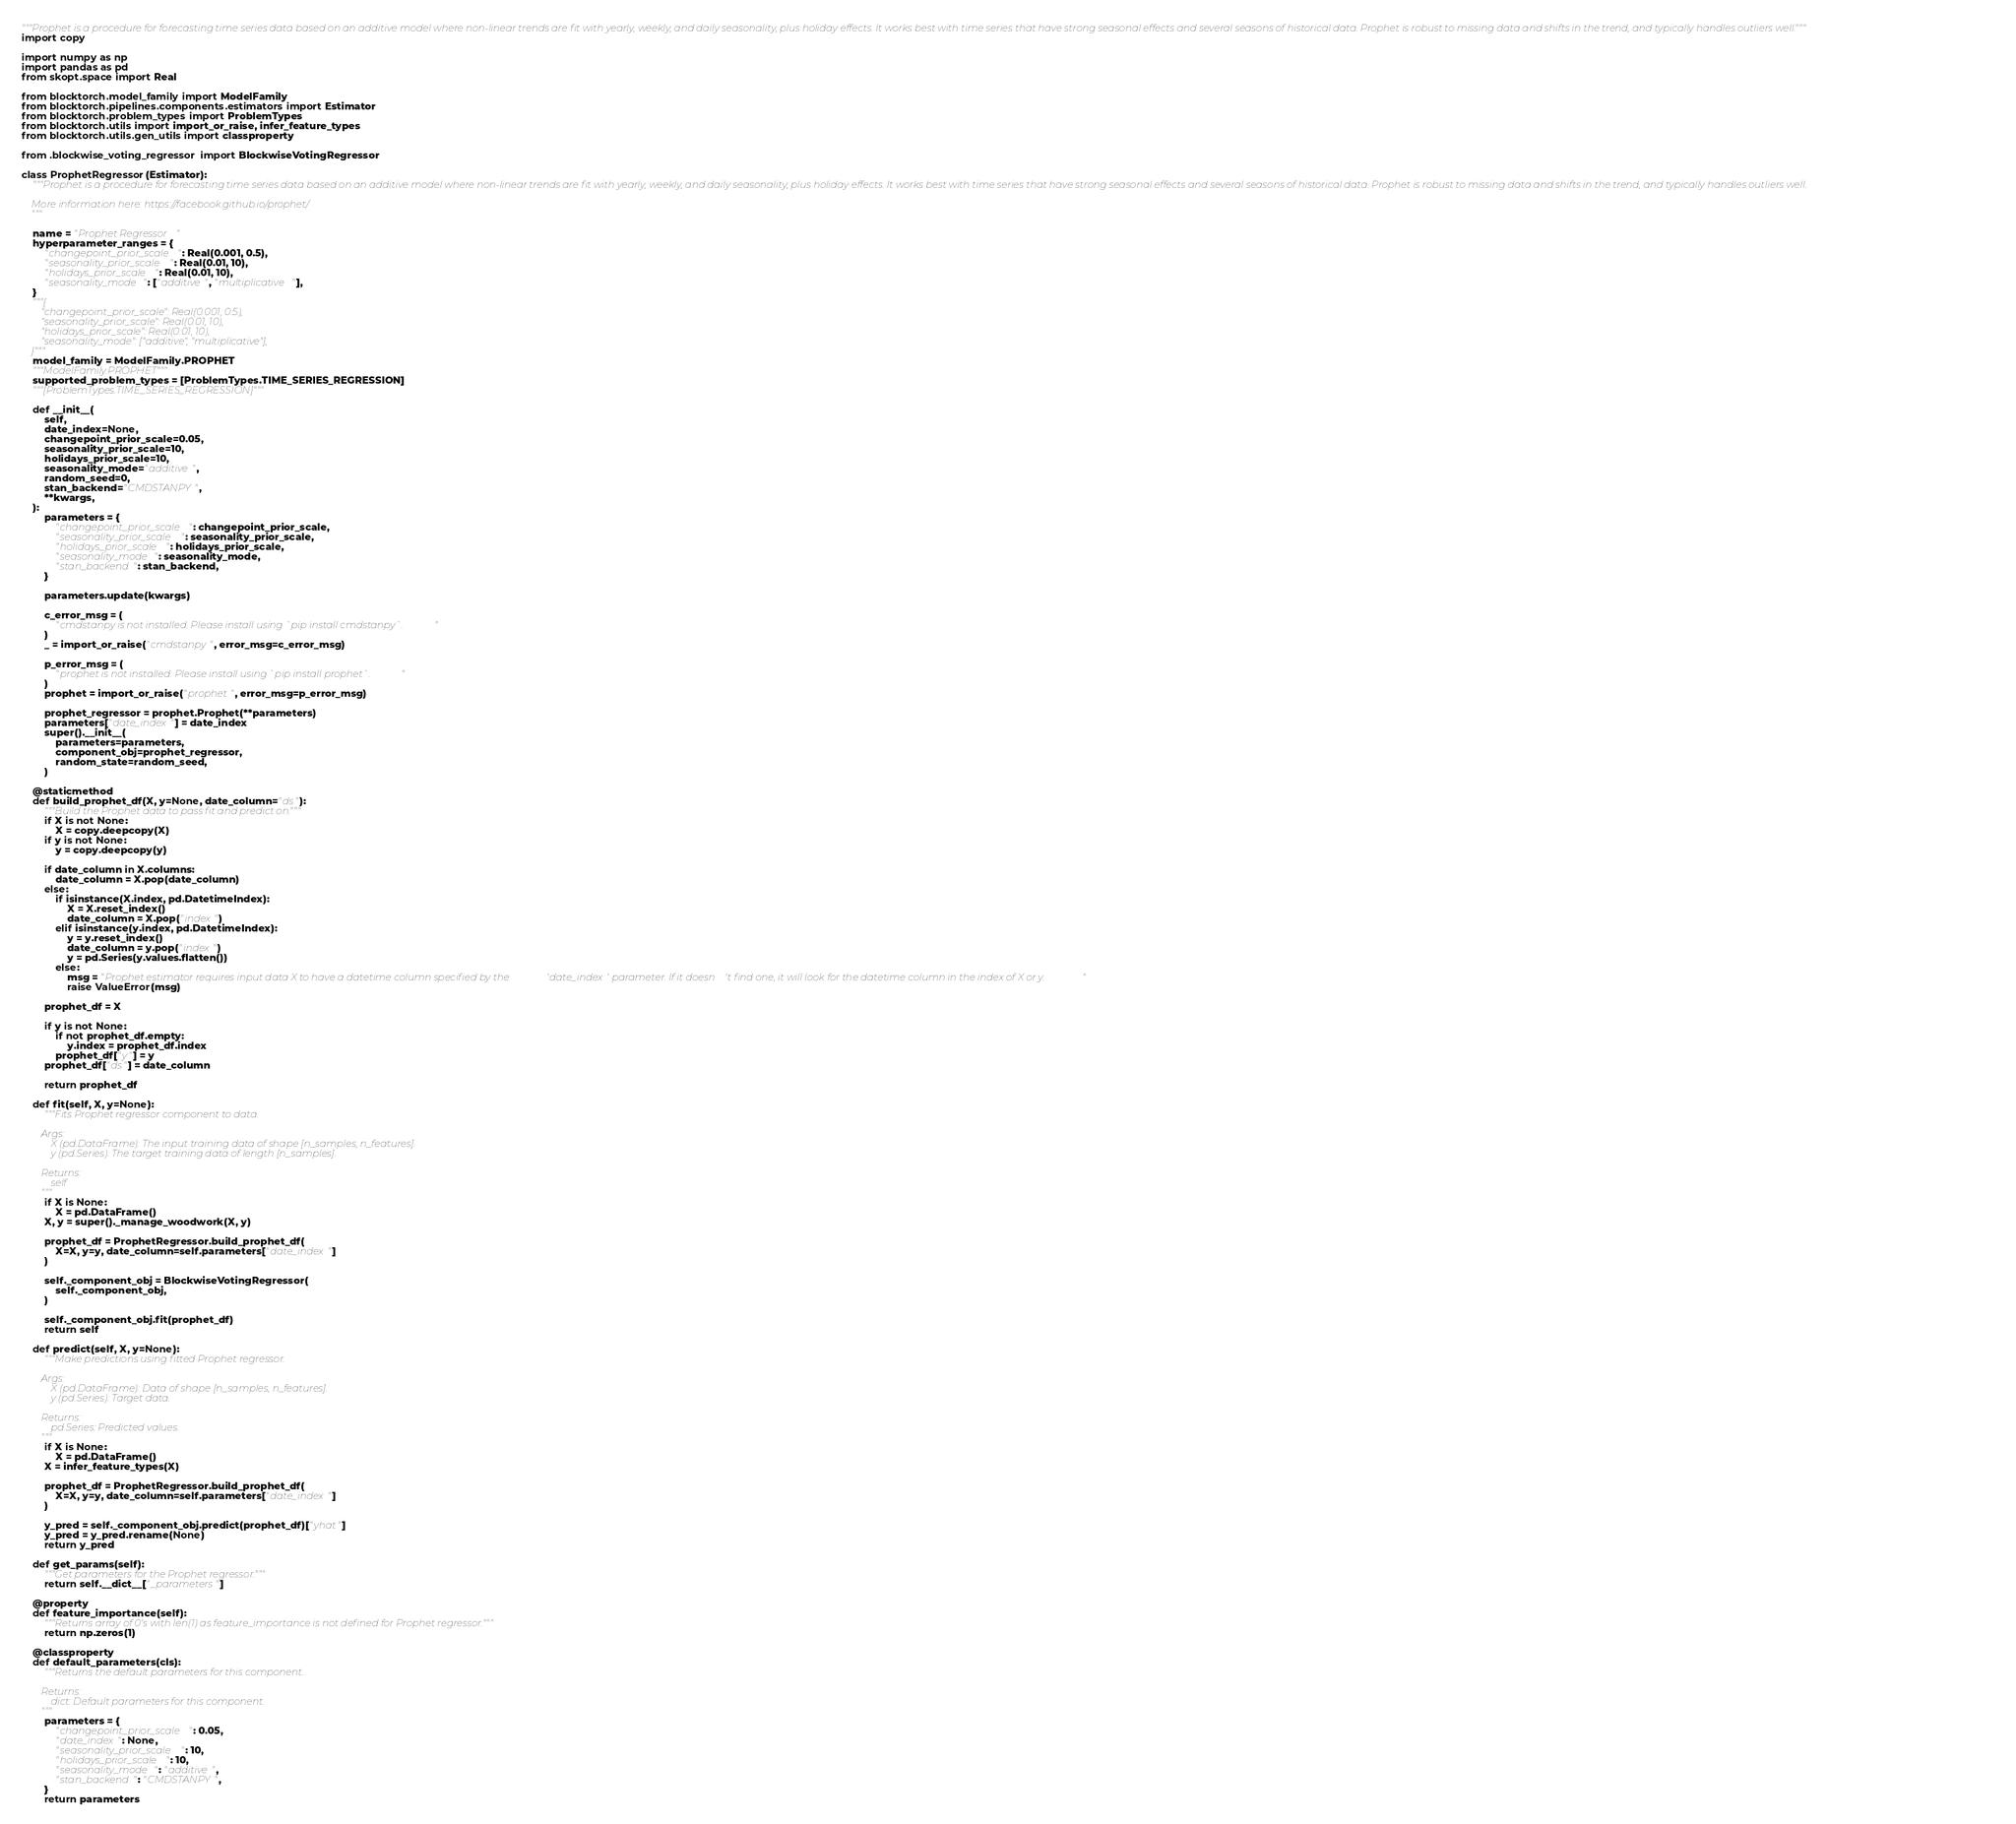<code> <loc_0><loc_0><loc_500><loc_500><_Python_>"""Prophet is a procedure for forecasting time series data based on an additive model where non-linear trends are fit with yearly, weekly, and daily seasonality, plus holiday effects. It works best with time series that have strong seasonal effects and several seasons of historical data. Prophet is robust to missing data and shifts in the trend, and typically handles outliers well."""
import copy

import numpy as np
import pandas as pd
from skopt.space import Real

from blocktorch.model_family import ModelFamily
from blocktorch.pipelines.components.estimators import Estimator
from blocktorch.problem_types import ProblemTypes
from blocktorch.utils import import_or_raise, infer_feature_types
from blocktorch.utils.gen_utils import classproperty

from .blockwise_voting_regressor import BlockwiseVotingRegressor

class ProphetRegressor(Estimator):
    """Prophet is a procedure for forecasting time series data based on an additive model where non-linear trends are fit with yearly, weekly, and daily seasonality, plus holiday effects. It works best with time series that have strong seasonal effects and several seasons of historical data. Prophet is robust to missing data and shifts in the trend, and typically handles outliers well.

    More information here: https://facebook.github.io/prophet/
    """

    name = "Prophet Regressor"
    hyperparameter_ranges = {
        "changepoint_prior_scale": Real(0.001, 0.5),
        "seasonality_prior_scale": Real(0.01, 10),
        "holidays_prior_scale": Real(0.01, 10),
        "seasonality_mode": ["additive", "multiplicative"],
    }
    """{
        "changepoint_prior_scale": Real(0.001, 0.5),
        "seasonality_prior_scale": Real(0.01, 10),
        "holidays_prior_scale": Real(0.01, 10),
        "seasonality_mode": ["additive", "multiplicative"],
    }"""
    model_family = ModelFamily.PROPHET
    """ModelFamily.PROPHET"""
    supported_problem_types = [ProblemTypes.TIME_SERIES_REGRESSION]
    """[ProblemTypes.TIME_SERIES_REGRESSION]"""

    def __init__(
        self,
        date_index=None,
        changepoint_prior_scale=0.05,
        seasonality_prior_scale=10,
        holidays_prior_scale=10,
        seasonality_mode="additive",
        random_seed=0,
        stan_backend="CMDSTANPY",
        **kwargs,
    ):
        parameters = {
            "changepoint_prior_scale": changepoint_prior_scale,
            "seasonality_prior_scale": seasonality_prior_scale,
            "holidays_prior_scale": holidays_prior_scale,
            "seasonality_mode": seasonality_mode,
            "stan_backend": stan_backend,
        }

        parameters.update(kwargs)

        c_error_msg = (
            "cmdstanpy is not installed. Please install using `pip install cmdstanpy`."
        )
        _ = import_or_raise("cmdstanpy", error_msg=c_error_msg)

        p_error_msg = (
            "prophet is not installed. Please install using `pip install prophet`."
        )
        prophet = import_or_raise("prophet", error_msg=p_error_msg)

        prophet_regressor = prophet.Prophet(**parameters)
        parameters["date_index"] = date_index
        super().__init__(
            parameters=parameters,
            component_obj=prophet_regressor,
            random_state=random_seed,
        )

    @staticmethod
    def build_prophet_df(X, y=None, date_column="ds"):
        """Build the Prophet data to pass fit and predict on."""
        if X is not None:
            X = copy.deepcopy(X)
        if y is not None:
            y = copy.deepcopy(y)

        if date_column in X.columns:
            date_column = X.pop(date_column)
        else:
            if isinstance(X.index, pd.DatetimeIndex):
                X = X.reset_index()
                date_column = X.pop("index")
            elif isinstance(y.index, pd.DatetimeIndex):
                y = y.reset_index()
                date_column = y.pop("index")
                y = pd.Series(y.values.flatten())
            else:
                msg = "Prophet estimator requires input data X to have a datetime column specified by the 'date_index' parameter. If it doesn't find one, it will look for the datetime column in the index of X or y."
                raise ValueError(msg)

        prophet_df = X

        if y is not None:
            if not prophet_df.empty:
                y.index = prophet_df.index
            prophet_df["y"] = y
        prophet_df["ds"] = date_column

        return prophet_df

    def fit(self, X, y=None):
        """Fits Prophet regressor component to data.

        Args:
            X (pd.DataFrame): The input training data of shape [n_samples, n_features].
            y (pd.Series): The target training data of length [n_samples].

        Returns:
            self
        """
        if X is None:
            X = pd.DataFrame()
        X, y = super()._manage_woodwork(X, y)

        prophet_df = ProphetRegressor.build_prophet_df(
            X=X, y=y, date_column=self.parameters["date_index"]
        )

        self._component_obj = BlockwiseVotingRegressor(
            self._component_obj,
        )

        self._component_obj.fit(prophet_df)
        return self

    def predict(self, X, y=None):
        """Make predictions using fitted Prophet regressor.

        Args:
            X (pd.DataFrame): Data of shape [n_samples, n_features].
            y (pd.Series): Target data.

        Returns:
            pd.Series: Predicted values.
        """
        if X is None:
            X = pd.DataFrame()
        X = infer_feature_types(X)

        prophet_df = ProphetRegressor.build_prophet_df(
            X=X, y=y, date_column=self.parameters["date_index"]
        )

        y_pred = self._component_obj.predict(prophet_df)["yhat"]
        y_pred = y_pred.rename(None)
        return y_pred

    def get_params(self):
        """Get parameters for the Prophet regressor."""
        return self.__dict__["_parameters"]

    @property
    def feature_importance(self):
        """Returns array of 0's with len(1) as feature_importance is not defined for Prophet regressor."""
        return np.zeros(1)

    @classproperty
    def default_parameters(cls):
        """Returns the default parameters for this component.

        Returns:
            dict: Default parameters for this component.
        """
        parameters = {
            "changepoint_prior_scale": 0.05,
            "date_index": None,
            "seasonality_prior_scale": 10,
            "holidays_prior_scale": 10,
            "seasonality_mode": "additive",
            "stan_backend": "CMDSTANPY",
        }
        return parameters
</code> 